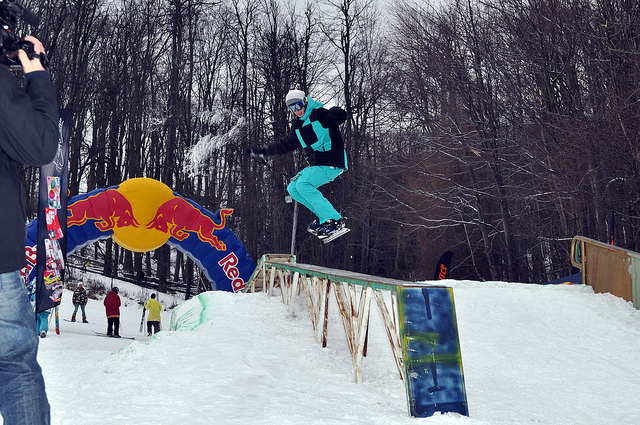Extract all visible text content from this image. Red B 